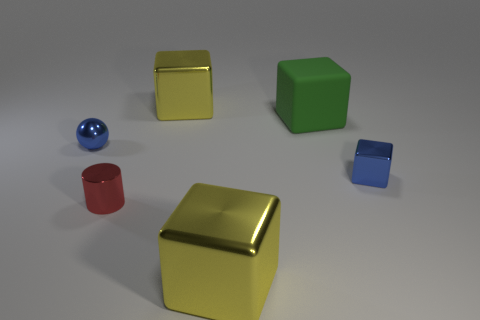Assuming these objects convey a sense of scale, which object might be considered the smallest, and why? Regarding scale, the small blue sphere would likely be considered the smallest object. Its diminutive size in relation to other items, the way it fits entirely within the shadow of the nearby cube, and the proportion of its shadow relative to others all suggest it is the smallest object in the scene. 